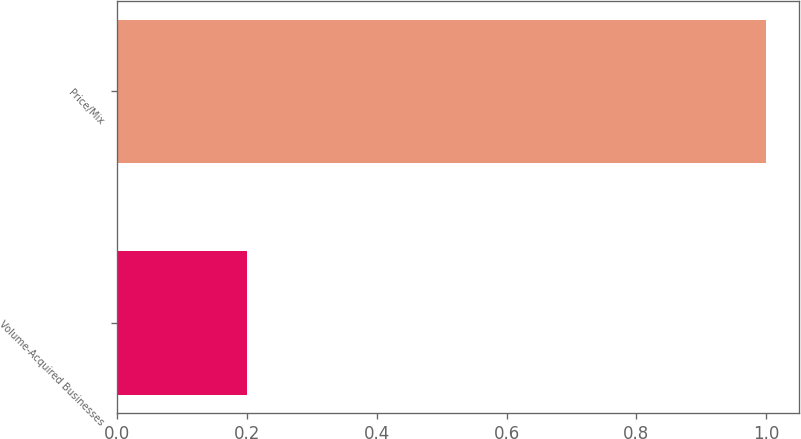Convert chart to OTSL. <chart><loc_0><loc_0><loc_500><loc_500><bar_chart><fcel>Volume-Acquired Businesses<fcel>Price/Mix<nl><fcel>0.2<fcel>1<nl></chart> 